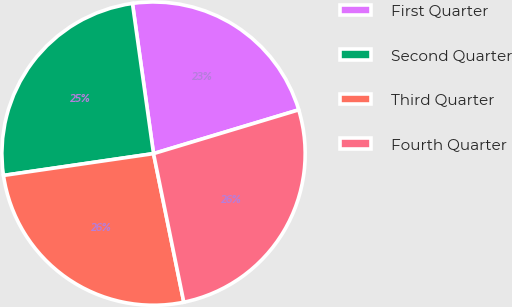<chart> <loc_0><loc_0><loc_500><loc_500><pie_chart><fcel>First Quarter<fcel>Second Quarter<fcel>Third Quarter<fcel>Fourth Quarter<nl><fcel>22.56%<fcel>25.08%<fcel>25.9%<fcel>26.46%<nl></chart> 